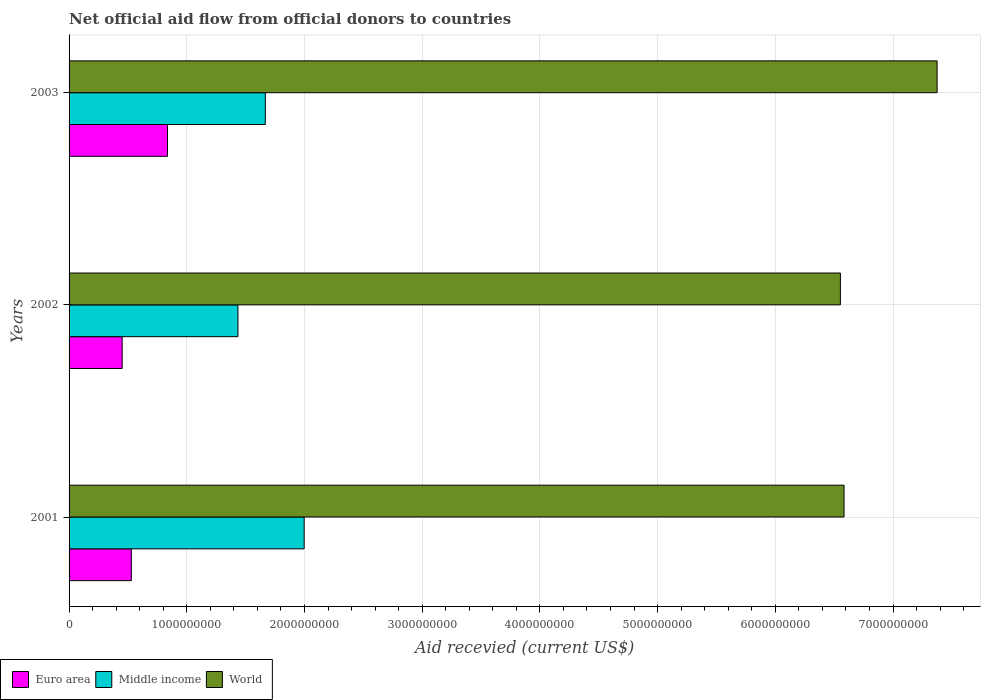How many different coloured bars are there?
Provide a succinct answer. 3. Are the number of bars per tick equal to the number of legend labels?
Your answer should be compact. Yes. Are the number of bars on each tick of the Y-axis equal?
Offer a terse response. Yes. How many bars are there on the 2nd tick from the top?
Your response must be concise. 3. What is the label of the 1st group of bars from the top?
Ensure brevity in your answer.  2003. In how many cases, is the number of bars for a given year not equal to the number of legend labels?
Your response must be concise. 0. What is the total aid received in World in 2001?
Offer a very short reply. 6.58e+09. Across all years, what is the maximum total aid received in Middle income?
Your answer should be compact. 2.00e+09. Across all years, what is the minimum total aid received in World?
Your answer should be compact. 6.55e+09. In which year was the total aid received in Euro area maximum?
Your answer should be very brief. 2003. In which year was the total aid received in World minimum?
Provide a succinct answer. 2002. What is the total total aid received in Middle income in the graph?
Provide a succinct answer. 5.10e+09. What is the difference between the total aid received in Middle income in 2001 and that in 2003?
Make the answer very short. 3.30e+08. What is the difference between the total aid received in World in 2001 and the total aid received in Middle income in 2002?
Offer a very short reply. 5.15e+09. What is the average total aid received in Middle income per year?
Your answer should be compact. 1.70e+09. In the year 2002, what is the difference between the total aid received in Euro area and total aid received in World?
Provide a succinct answer. -6.10e+09. In how many years, is the total aid received in Euro area greater than 4000000000 US$?
Provide a succinct answer. 0. What is the ratio of the total aid received in World in 2001 to that in 2003?
Your answer should be very brief. 0.89. Is the total aid received in Middle income in 2001 less than that in 2003?
Offer a very short reply. No. What is the difference between the highest and the second highest total aid received in Middle income?
Your response must be concise. 3.30e+08. What is the difference between the highest and the lowest total aid received in Middle income?
Provide a succinct answer. 5.63e+08. In how many years, is the total aid received in World greater than the average total aid received in World taken over all years?
Your answer should be very brief. 1. Is the sum of the total aid received in World in 2001 and 2003 greater than the maximum total aid received in Middle income across all years?
Give a very brief answer. Yes. What does the 1st bar from the top in 2002 represents?
Give a very brief answer. World. How many bars are there?
Offer a very short reply. 9. How many years are there in the graph?
Your answer should be compact. 3. What is the difference between two consecutive major ticks on the X-axis?
Offer a very short reply. 1.00e+09. Are the values on the major ticks of X-axis written in scientific E-notation?
Provide a short and direct response. No. Does the graph contain any zero values?
Offer a terse response. No. Where does the legend appear in the graph?
Ensure brevity in your answer.  Bottom left. How many legend labels are there?
Provide a succinct answer. 3. How are the legend labels stacked?
Your response must be concise. Horizontal. What is the title of the graph?
Offer a terse response. Net official aid flow from official donors to countries. What is the label or title of the X-axis?
Provide a short and direct response. Aid recevied (current US$). What is the label or title of the Y-axis?
Ensure brevity in your answer.  Years. What is the Aid recevied (current US$) of Euro area in 2001?
Keep it short and to the point. 5.29e+08. What is the Aid recevied (current US$) in Middle income in 2001?
Give a very brief answer. 2.00e+09. What is the Aid recevied (current US$) of World in 2001?
Provide a short and direct response. 6.58e+09. What is the Aid recevied (current US$) in Euro area in 2002?
Keep it short and to the point. 4.51e+08. What is the Aid recevied (current US$) of Middle income in 2002?
Offer a terse response. 1.43e+09. What is the Aid recevied (current US$) of World in 2002?
Offer a terse response. 6.55e+09. What is the Aid recevied (current US$) of Euro area in 2003?
Offer a terse response. 8.36e+08. What is the Aid recevied (current US$) of Middle income in 2003?
Provide a succinct answer. 1.67e+09. What is the Aid recevied (current US$) in World in 2003?
Provide a short and direct response. 7.37e+09. Across all years, what is the maximum Aid recevied (current US$) of Euro area?
Keep it short and to the point. 8.36e+08. Across all years, what is the maximum Aid recevied (current US$) in Middle income?
Offer a very short reply. 2.00e+09. Across all years, what is the maximum Aid recevied (current US$) of World?
Ensure brevity in your answer.  7.37e+09. Across all years, what is the minimum Aid recevied (current US$) of Euro area?
Your answer should be very brief. 4.51e+08. Across all years, what is the minimum Aid recevied (current US$) in Middle income?
Your response must be concise. 1.43e+09. Across all years, what is the minimum Aid recevied (current US$) of World?
Ensure brevity in your answer.  6.55e+09. What is the total Aid recevied (current US$) in Euro area in the graph?
Provide a succinct answer. 1.82e+09. What is the total Aid recevied (current US$) of Middle income in the graph?
Make the answer very short. 5.10e+09. What is the total Aid recevied (current US$) in World in the graph?
Your answer should be compact. 2.05e+1. What is the difference between the Aid recevied (current US$) of Euro area in 2001 and that in 2002?
Your answer should be compact. 7.77e+07. What is the difference between the Aid recevied (current US$) in Middle income in 2001 and that in 2002?
Your response must be concise. 5.63e+08. What is the difference between the Aid recevied (current US$) of World in 2001 and that in 2002?
Offer a very short reply. 3.09e+07. What is the difference between the Aid recevied (current US$) of Euro area in 2001 and that in 2003?
Ensure brevity in your answer.  -3.08e+08. What is the difference between the Aid recevied (current US$) of Middle income in 2001 and that in 2003?
Your answer should be very brief. 3.30e+08. What is the difference between the Aid recevied (current US$) in World in 2001 and that in 2003?
Provide a short and direct response. -7.91e+08. What is the difference between the Aid recevied (current US$) of Euro area in 2002 and that in 2003?
Make the answer very short. -3.85e+08. What is the difference between the Aid recevied (current US$) of Middle income in 2002 and that in 2003?
Your answer should be compact. -2.33e+08. What is the difference between the Aid recevied (current US$) of World in 2002 and that in 2003?
Offer a terse response. -8.22e+08. What is the difference between the Aid recevied (current US$) in Euro area in 2001 and the Aid recevied (current US$) in Middle income in 2002?
Offer a terse response. -9.06e+08. What is the difference between the Aid recevied (current US$) of Euro area in 2001 and the Aid recevied (current US$) of World in 2002?
Provide a short and direct response. -6.02e+09. What is the difference between the Aid recevied (current US$) in Middle income in 2001 and the Aid recevied (current US$) in World in 2002?
Provide a short and direct response. -4.56e+09. What is the difference between the Aid recevied (current US$) of Euro area in 2001 and the Aid recevied (current US$) of Middle income in 2003?
Your answer should be very brief. -1.14e+09. What is the difference between the Aid recevied (current US$) of Euro area in 2001 and the Aid recevied (current US$) of World in 2003?
Keep it short and to the point. -6.85e+09. What is the difference between the Aid recevied (current US$) of Middle income in 2001 and the Aid recevied (current US$) of World in 2003?
Make the answer very short. -5.38e+09. What is the difference between the Aid recevied (current US$) in Euro area in 2002 and the Aid recevied (current US$) in Middle income in 2003?
Offer a terse response. -1.22e+09. What is the difference between the Aid recevied (current US$) in Euro area in 2002 and the Aid recevied (current US$) in World in 2003?
Your answer should be compact. -6.92e+09. What is the difference between the Aid recevied (current US$) in Middle income in 2002 and the Aid recevied (current US$) in World in 2003?
Your answer should be compact. -5.94e+09. What is the average Aid recevied (current US$) of Euro area per year?
Provide a short and direct response. 6.05e+08. What is the average Aid recevied (current US$) of Middle income per year?
Your answer should be compact. 1.70e+09. What is the average Aid recevied (current US$) in World per year?
Make the answer very short. 6.84e+09. In the year 2001, what is the difference between the Aid recevied (current US$) in Euro area and Aid recevied (current US$) in Middle income?
Provide a succinct answer. -1.47e+09. In the year 2001, what is the difference between the Aid recevied (current US$) in Euro area and Aid recevied (current US$) in World?
Offer a very short reply. -6.05e+09. In the year 2001, what is the difference between the Aid recevied (current US$) in Middle income and Aid recevied (current US$) in World?
Offer a very short reply. -4.59e+09. In the year 2002, what is the difference between the Aid recevied (current US$) in Euro area and Aid recevied (current US$) in Middle income?
Give a very brief answer. -9.83e+08. In the year 2002, what is the difference between the Aid recevied (current US$) of Euro area and Aid recevied (current US$) of World?
Keep it short and to the point. -6.10e+09. In the year 2002, what is the difference between the Aid recevied (current US$) in Middle income and Aid recevied (current US$) in World?
Offer a terse response. -5.12e+09. In the year 2003, what is the difference between the Aid recevied (current US$) in Euro area and Aid recevied (current US$) in Middle income?
Your response must be concise. -8.31e+08. In the year 2003, what is the difference between the Aid recevied (current US$) of Euro area and Aid recevied (current US$) of World?
Offer a very short reply. -6.54e+09. In the year 2003, what is the difference between the Aid recevied (current US$) of Middle income and Aid recevied (current US$) of World?
Your response must be concise. -5.71e+09. What is the ratio of the Aid recevied (current US$) in Euro area in 2001 to that in 2002?
Provide a succinct answer. 1.17. What is the ratio of the Aid recevied (current US$) in Middle income in 2001 to that in 2002?
Provide a short and direct response. 1.39. What is the ratio of the Aid recevied (current US$) in World in 2001 to that in 2002?
Offer a terse response. 1. What is the ratio of the Aid recevied (current US$) of Euro area in 2001 to that in 2003?
Provide a succinct answer. 0.63. What is the ratio of the Aid recevied (current US$) in Middle income in 2001 to that in 2003?
Your answer should be very brief. 1.2. What is the ratio of the Aid recevied (current US$) in World in 2001 to that in 2003?
Ensure brevity in your answer.  0.89. What is the ratio of the Aid recevied (current US$) in Euro area in 2002 to that in 2003?
Make the answer very short. 0.54. What is the ratio of the Aid recevied (current US$) in Middle income in 2002 to that in 2003?
Keep it short and to the point. 0.86. What is the ratio of the Aid recevied (current US$) in World in 2002 to that in 2003?
Offer a very short reply. 0.89. What is the difference between the highest and the second highest Aid recevied (current US$) in Euro area?
Provide a short and direct response. 3.08e+08. What is the difference between the highest and the second highest Aid recevied (current US$) in Middle income?
Give a very brief answer. 3.30e+08. What is the difference between the highest and the second highest Aid recevied (current US$) of World?
Keep it short and to the point. 7.91e+08. What is the difference between the highest and the lowest Aid recevied (current US$) of Euro area?
Your answer should be compact. 3.85e+08. What is the difference between the highest and the lowest Aid recevied (current US$) in Middle income?
Ensure brevity in your answer.  5.63e+08. What is the difference between the highest and the lowest Aid recevied (current US$) in World?
Your answer should be compact. 8.22e+08. 